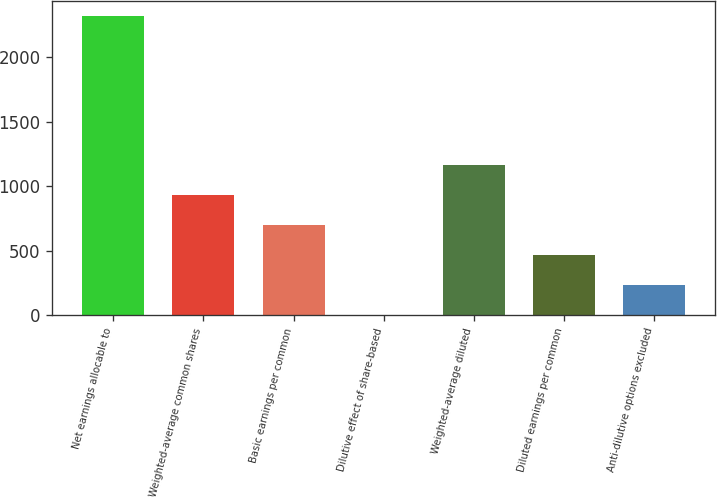<chart> <loc_0><loc_0><loc_500><loc_500><bar_chart><fcel>Net earnings allocable to<fcel>Weighted-average common shares<fcel>Basic earnings per common<fcel>Dilutive effect of share-based<fcel>Weighted-average diluted<fcel>Diluted earnings per common<fcel>Anti-dilutive options excluded<nl><fcel>2320<fcel>929.8<fcel>698.1<fcel>3<fcel>1161.5<fcel>466.4<fcel>234.7<nl></chart> 